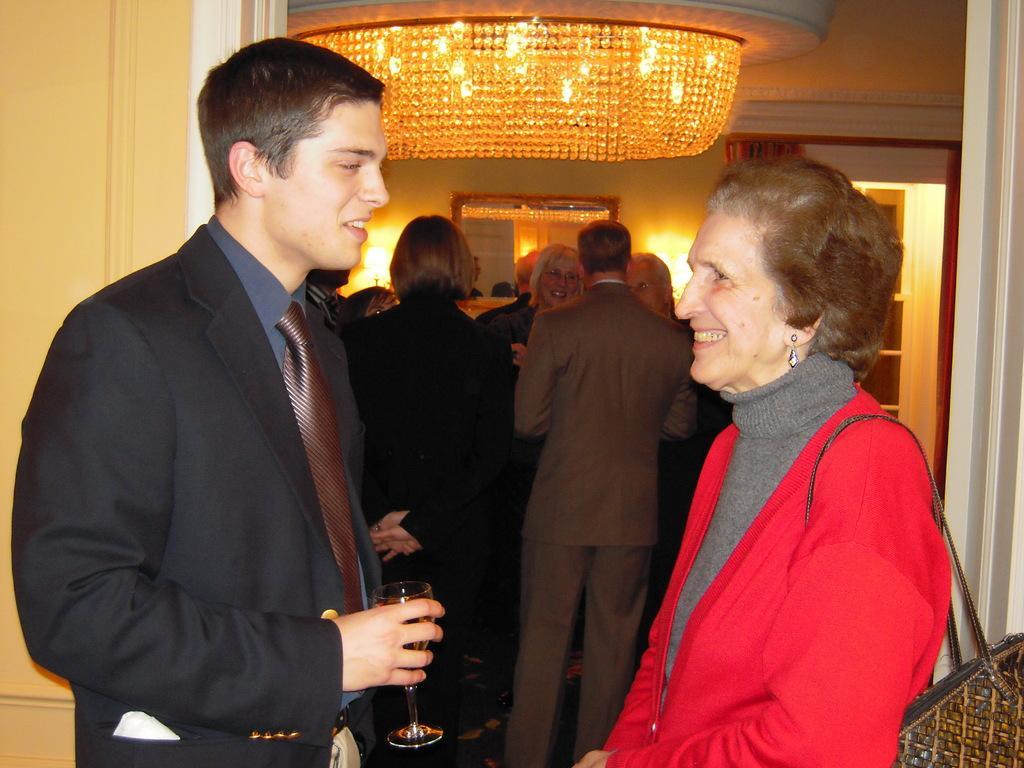Describe this image in one or two sentences. In this image we can see a man and a lady standing and we can see a glass in his hand. In the background there are people. At the top we can see chandelier. In the background there is a wall, door and lights. 